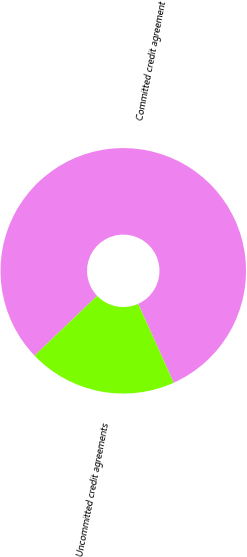Convert chart to OTSL. <chart><loc_0><loc_0><loc_500><loc_500><pie_chart><fcel>Committed credit agreement<fcel>Uncommitted credit agreements<nl><fcel>80.4%<fcel>19.6%<nl></chart> 